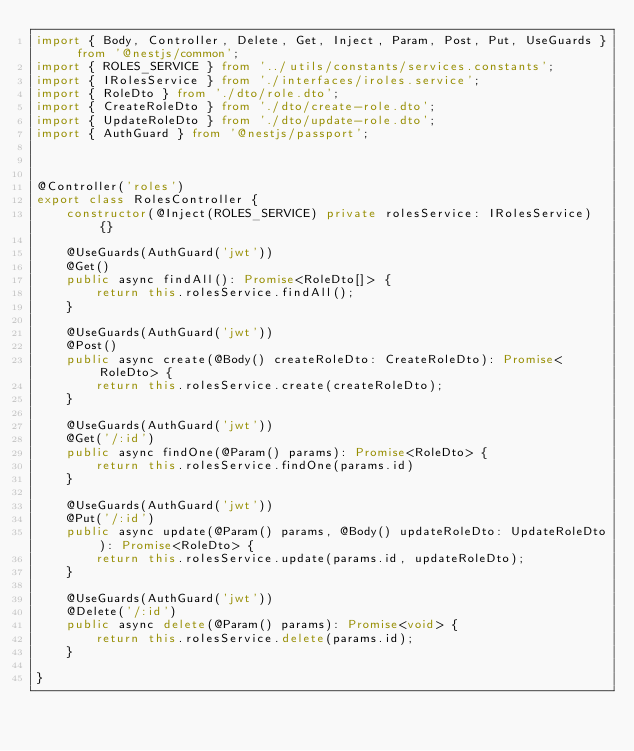<code> <loc_0><loc_0><loc_500><loc_500><_TypeScript_>import { Body, Controller, Delete, Get, Inject, Param, Post, Put, UseGuards } from '@nestjs/common';
import { ROLES_SERVICE } from '../utils/constants/services.constants';
import { IRolesService } from './interfaces/iroles.service';
import { RoleDto } from './dto/role.dto';
import { CreateRoleDto } from './dto/create-role.dto';
import { UpdateRoleDto } from './dto/update-role.dto';
import { AuthGuard } from '@nestjs/passport';



@Controller('roles')
export class RolesController {
    constructor(@Inject(ROLES_SERVICE) private rolesService: IRolesService) {}

    @UseGuards(AuthGuard('jwt'))
    @Get()
    public async findAll(): Promise<RoleDto[]> {
        return this.rolesService.findAll();
    }

    @UseGuards(AuthGuard('jwt'))
    @Post()
    public async create(@Body() createRoleDto: CreateRoleDto): Promise<RoleDto> {
        return this.rolesService.create(createRoleDto);
    }

    @UseGuards(AuthGuard('jwt'))
    @Get('/:id')
    public async findOne(@Param() params): Promise<RoleDto> {
        return this.rolesService.findOne(params.id)
    }

    @UseGuards(AuthGuard('jwt'))
    @Put('/:id')
    public async update(@Param() params, @Body() updateRoleDto: UpdateRoleDto): Promise<RoleDto> {
        return this.rolesService.update(params.id, updateRoleDto);
    }

    @UseGuards(AuthGuard('jwt'))
    @Delete('/:id')
    public async delete(@Param() params): Promise<void> {
        return this.rolesService.delete(params.id);
    }

}
</code> 